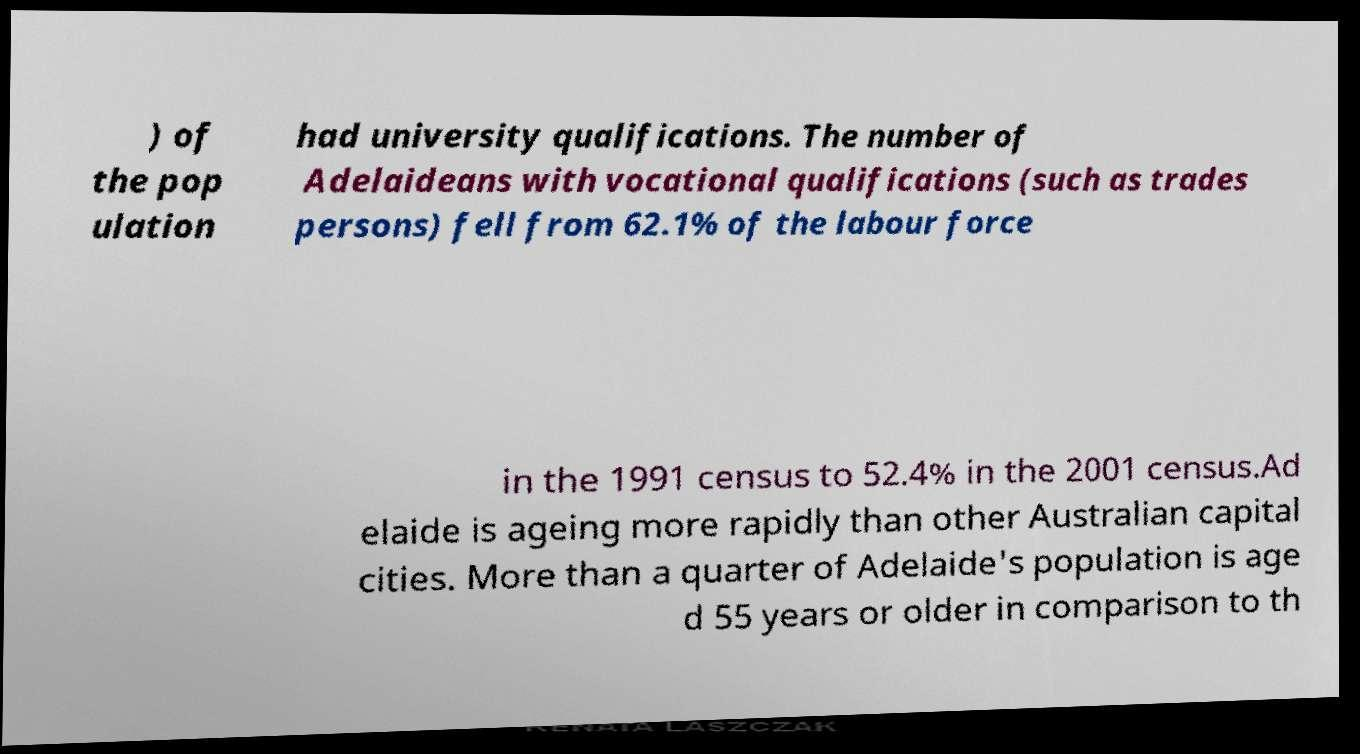Please read and relay the text visible in this image. What does it say? ) of the pop ulation had university qualifications. The number of Adelaideans with vocational qualifications (such as trades persons) fell from 62.1% of the labour force in the 1991 census to 52.4% in the 2001 census.Ad elaide is ageing more rapidly than other Australian capital cities. More than a quarter of Adelaide's population is age d 55 years or older in comparison to th 